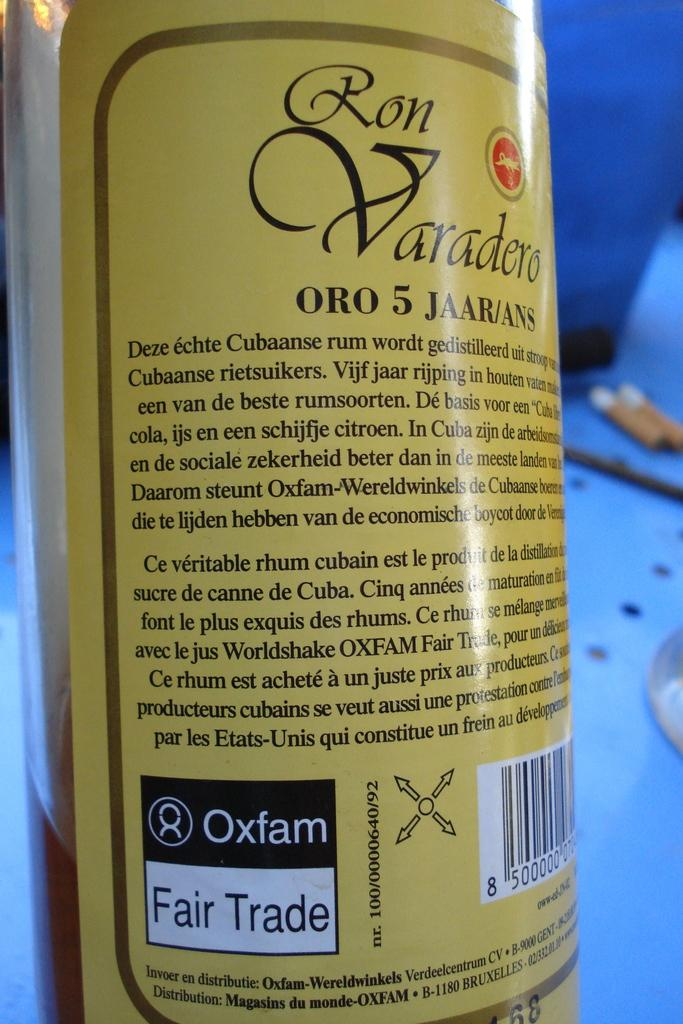<image>
Give a short and clear explanation of the subsequent image. The bottle of Ron Varadero is a fair trade product 